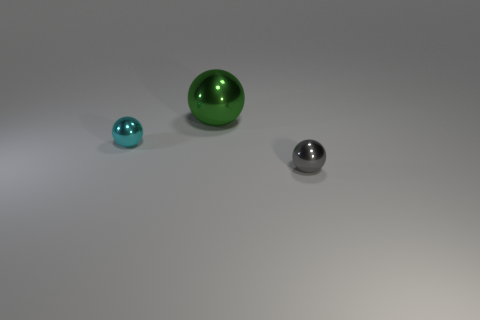What is the shape of the tiny gray thing? sphere 